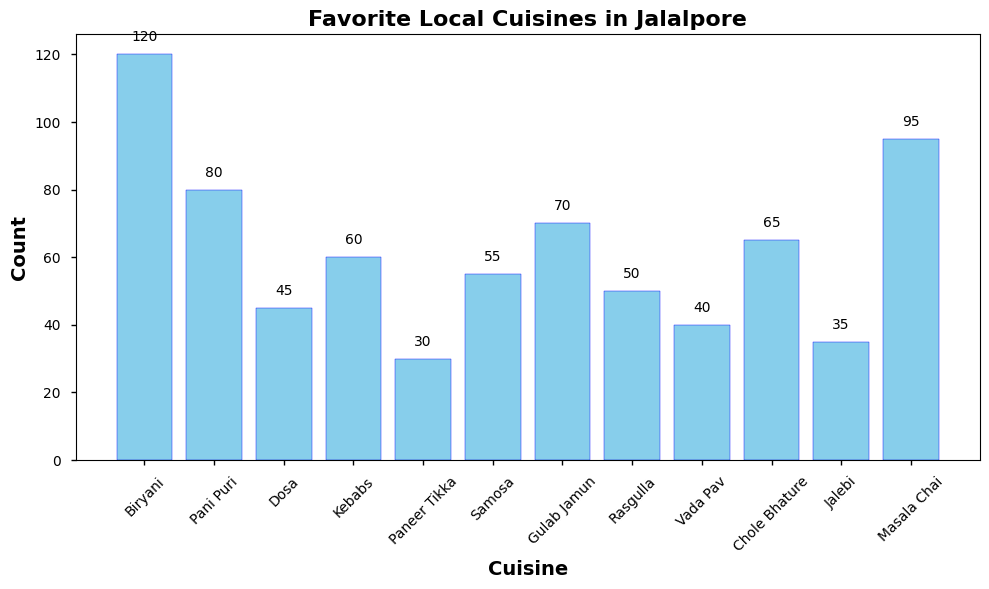Which cuisine is the most popular in Jalalpore according to the survey? The tallest bar in the bar chart represents Biryani with a count of 120, indicating it is the most popular cuisine.
Answer: Biryani What is the total count for Dosa and Paneer Tikka? To find the total, add the counts of Dosa (45) and Paneer Tikka (30). 45 + 30 = 75.
Answer: 75 Which has a higher count, Samosa or Rasgulla? By comparing the heights of the bars, Samosa has a count of 55 while Rasgulla has a count of 50, making Samosa higher.
Answer: Samosa What is the difference in counts between Masala Chai and Vada Pav? Subtract the count of Vada Pav (40) from Masala Chai (95). 95 - 40 = 55.
Answer: 55 Which cuisine ranks second in popularity? The second tallest bar in the bar chart represents Masala Chai with a count of 95.
Answer: Masala Chai How many cuisines have a count greater than 50? By looking at the heights of the bars, Biryani, Pani Puri, Kebabs, Gulab Jamun, Chole Bhature, Samosa, and Masala Chai each have counts greater than 50, making a total of 7 cuisines.
Answer: 7 Which cuisines have counts that are within 10 units of each other? Kebabs (60) and Chole Bhature (65) have counts within 10 units of each other. Samosa (55) and Rasgulla (50) also have counts within 10 units of each other.
Answer: Kebabs & Chole Bhature; Samosa & Rasgulla What is the combined count of the top three cuisines? The top three cuisines are Biryani (120), Masala Chai (95), and Pani Puri (80). Their combined count is 120 + 95 + 80 = 295.
Answer: 295 Which cuisine is least popular according to the survey? The shortest bar represents Paneer Tikka with a count of 30, indicating it is the least popular cuisine.
Answer: Paneer Tikka Is the count of Gulab Jamun greater than the count of Jalebi? Comparing the two bars, the count of Gulab Jamun (70) is greater than that of Jalebi (35).
Answer: Yes 